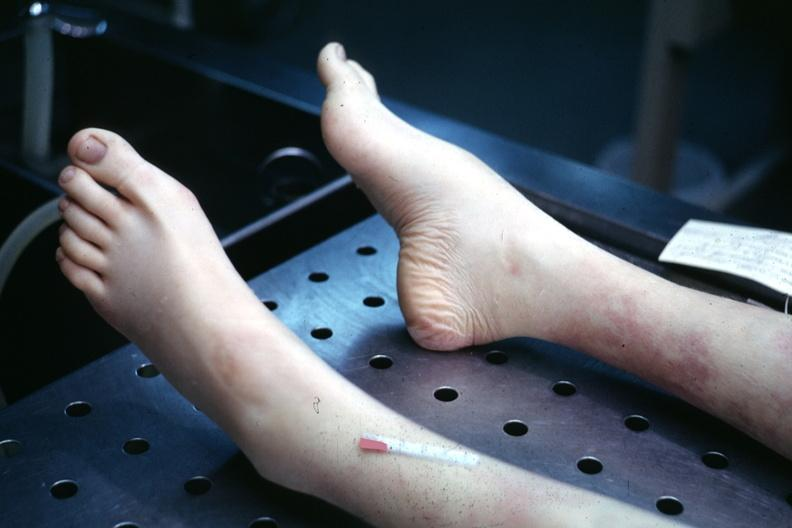what is present?
Answer the question using a single word or phrase. Feet 